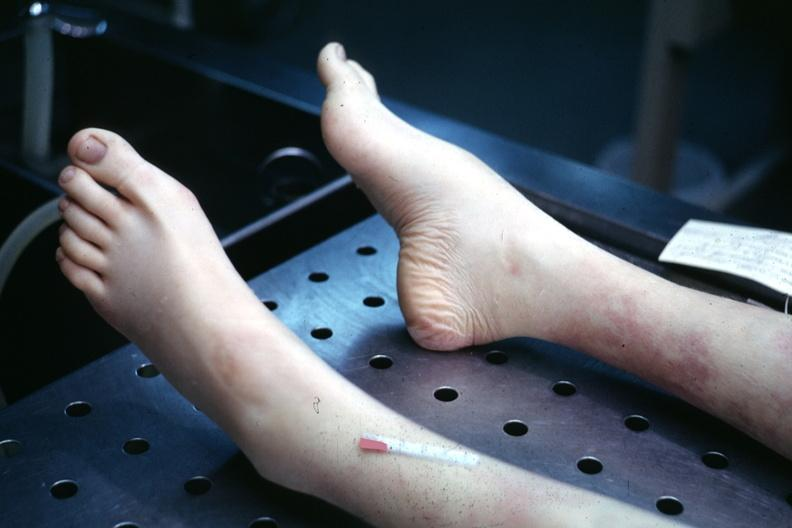what is present?
Answer the question using a single word or phrase. Feet 